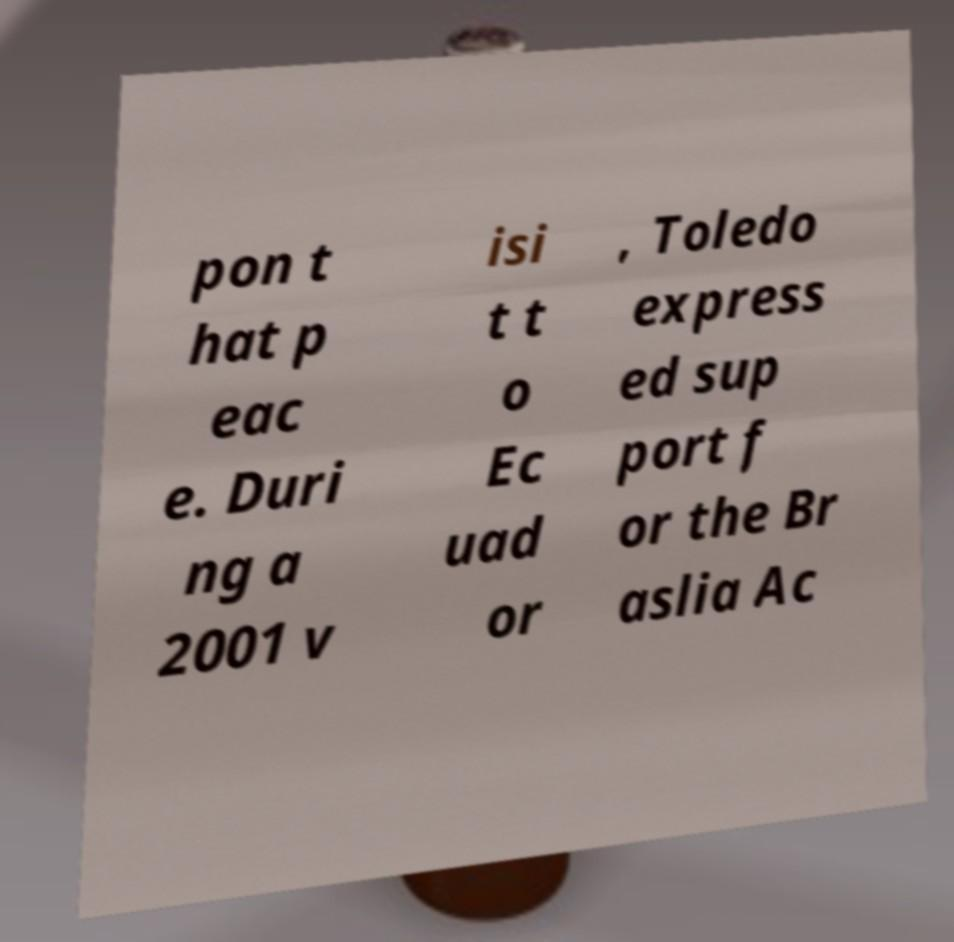Can you read and provide the text displayed in the image?This photo seems to have some interesting text. Can you extract and type it out for me? pon t hat p eac e. Duri ng a 2001 v isi t t o Ec uad or , Toledo express ed sup port f or the Br aslia Ac 